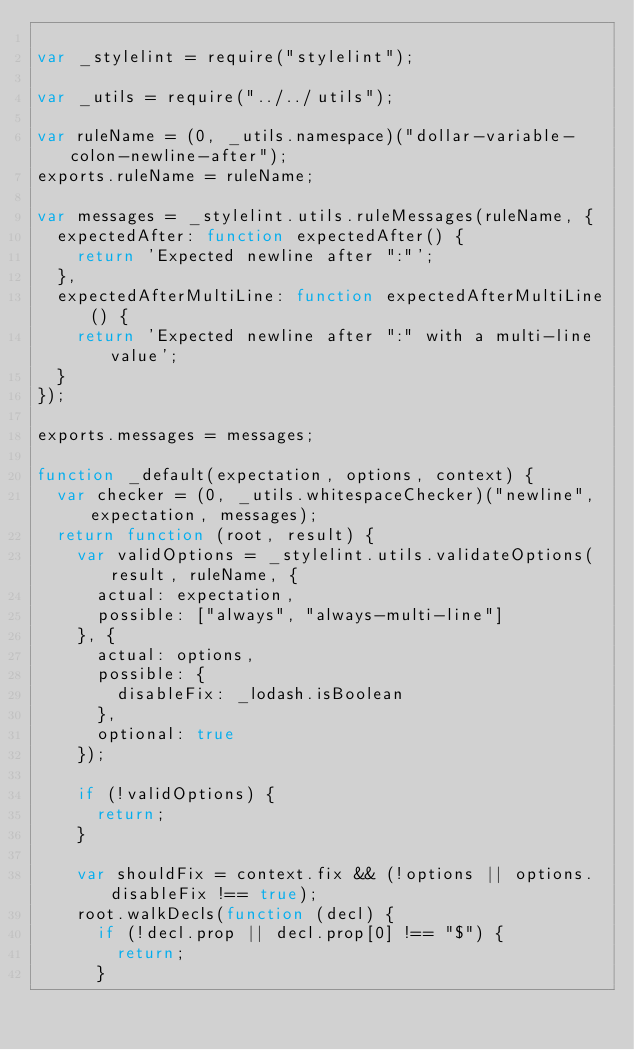Convert code to text. <code><loc_0><loc_0><loc_500><loc_500><_JavaScript_>
var _stylelint = require("stylelint");

var _utils = require("../../utils");

var ruleName = (0, _utils.namespace)("dollar-variable-colon-newline-after");
exports.ruleName = ruleName;

var messages = _stylelint.utils.ruleMessages(ruleName, {
  expectedAfter: function expectedAfter() {
    return 'Expected newline after ":"';
  },
  expectedAfterMultiLine: function expectedAfterMultiLine() {
    return 'Expected newline after ":" with a multi-line value';
  }
});

exports.messages = messages;

function _default(expectation, options, context) {
  var checker = (0, _utils.whitespaceChecker)("newline", expectation, messages);
  return function (root, result) {
    var validOptions = _stylelint.utils.validateOptions(result, ruleName, {
      actual: expectation,
      possible: ["always", "always-multi-line"]
    }, {
      actual: options,
      possible: {
        disableFix: _lodash.isBoolean
      },
      optional: true
    });

    if (!validOptions) {
      return;
    }

    var shouldFix = context.fix && (!options || options.disableFix !== true);
    root.walkDecls(function (decl) {
      if (!decl.prop || decl.prop[0] !== "$") {
        return;
      }
</code> 